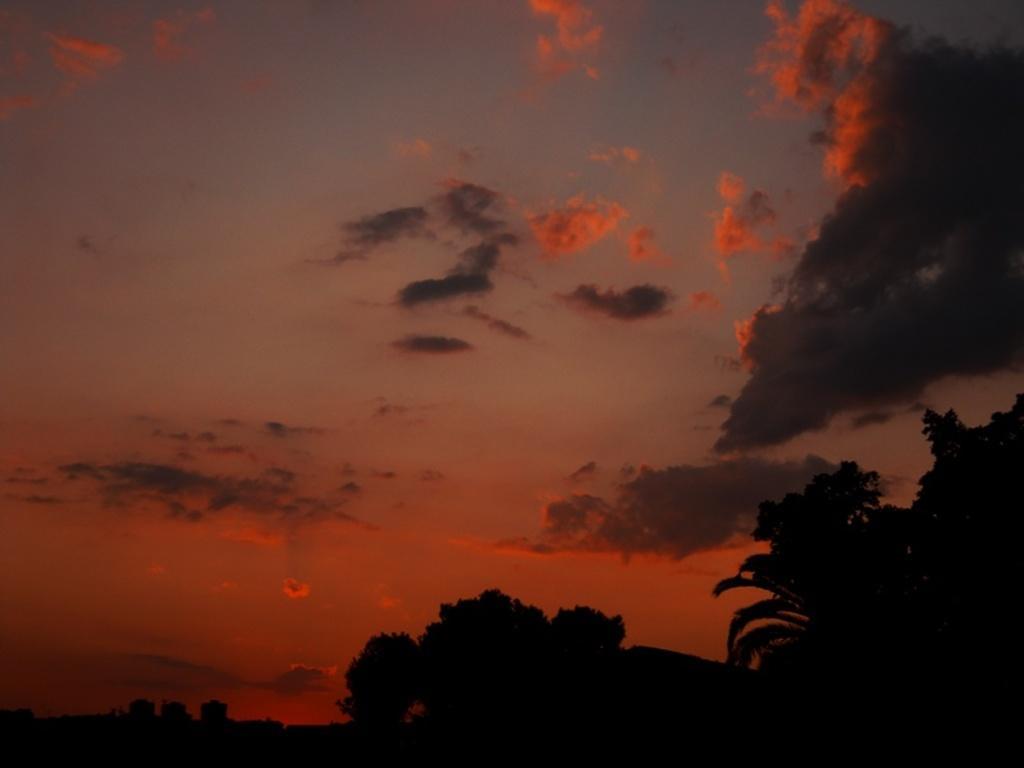In one or two sentences, can you explain what this image depicts? In this image I can see many trees. In the background there are clouds and the sky. I can see some clouds are in orange color. 